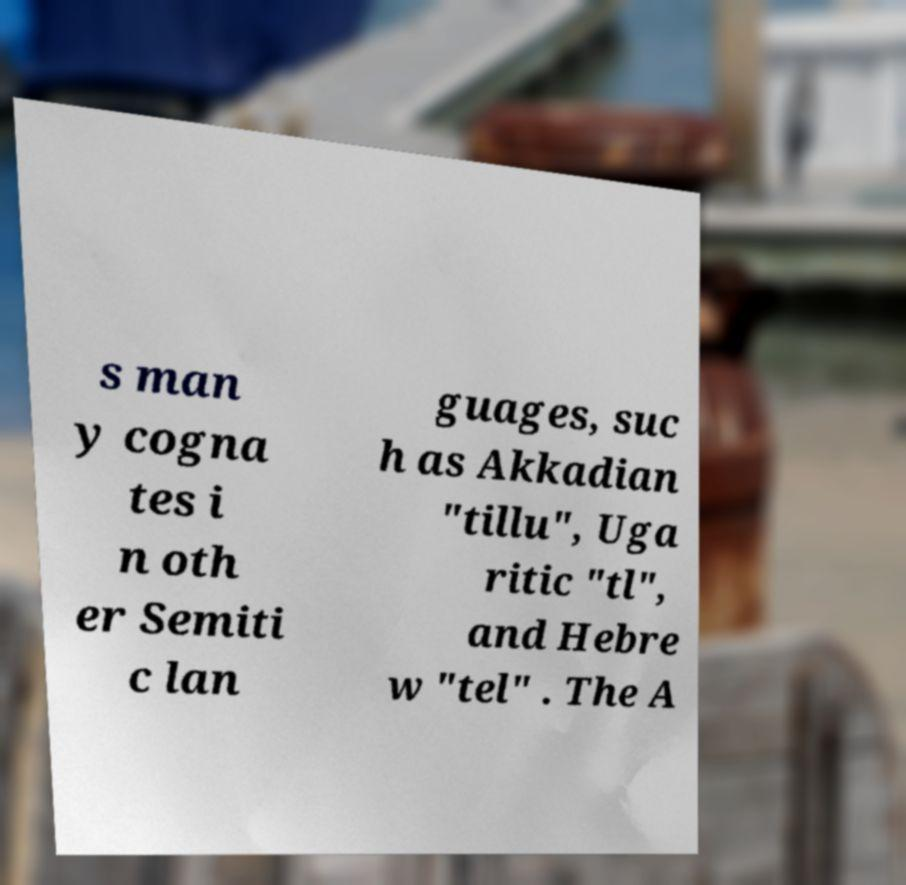Could you assist in decoding the text presented in this image and type it out clearly? s man y cogna tes i n oth er Semiti c lan guages, suc h as Akkadian "tillu", Uga ritic "tl", and Hebre w "tel" . The A 